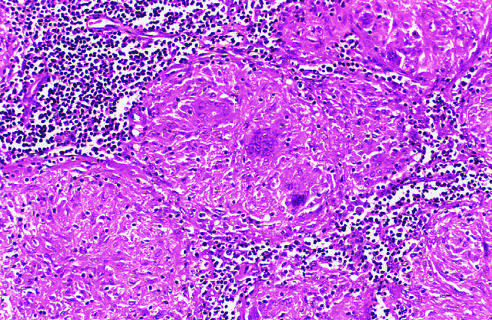what shows several multinucleate giant cells?
Answer the question using a single word or phrase. The granuloma 